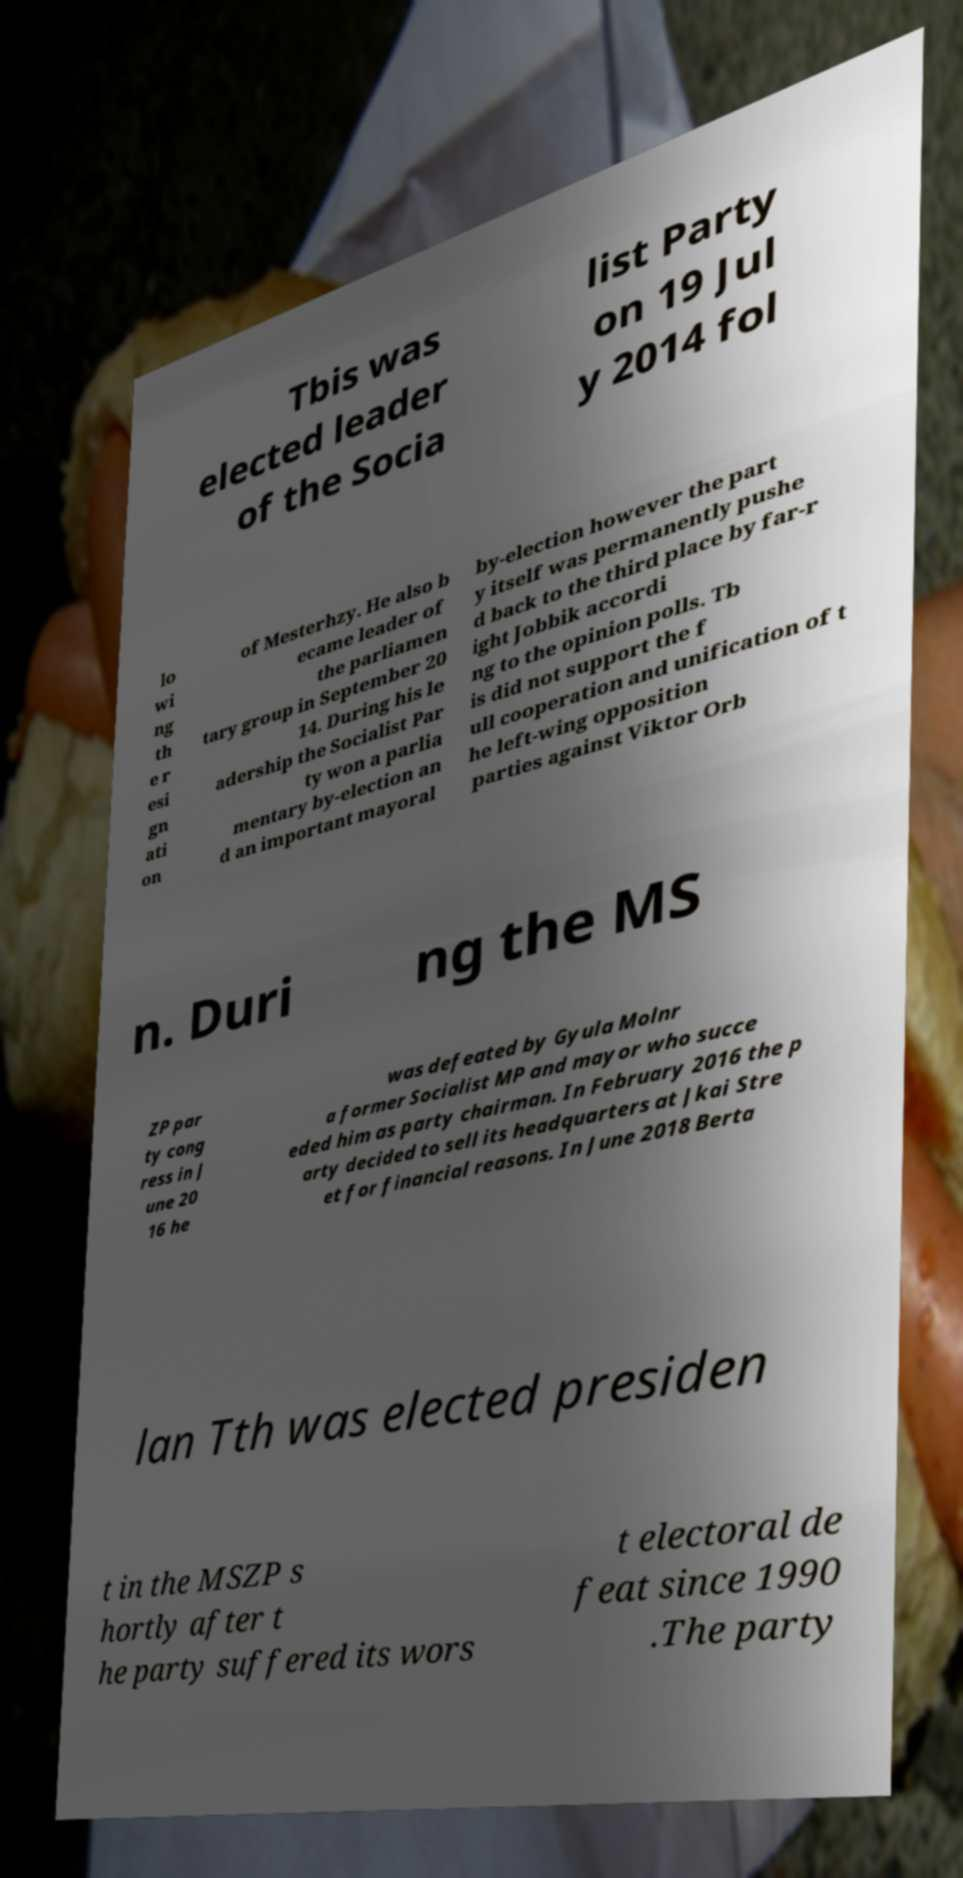For documentation purposes, I need the text within this image transcribed. Could you provide that? Tbis was elected leader of the Socia list Party on 19 Jul y 2014 fol lo wi ng th e r esi gn ati on of Mesterhzy. He also b ecame leader of the parliamen tary group in September 20 14. During his le adership the Socialist Par ty won a parlia mentary by-election an d an important mayoral by-election however the part y itself was permanently pushe d back to the third place by far-r ight Jobbik accordi ng to the opinion polls. Tb is did not support the f ull cooperation and unification of t he left-wing opposition parties against Viktor Orb n. Duri ng the MS ZP par ty cong ress in J une 20 16 he was defeated by Gyula Molnr a former Socialist MP and mayor who succe eded him as party chairman. In February 2016 the p arty decided to sell its headquarters at Jkai Stre et for financial reasons. In June 2018 Berta lan Tth was elected presiden t in the MSZP s hortly after t he party suffered its wors t electoral de feat since 1990 .The party 